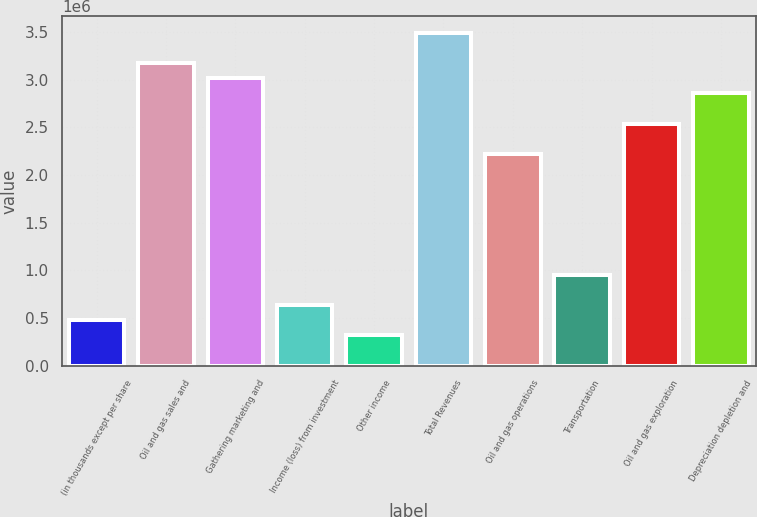Convert chart. <chart><loc_0><loc_0><loc_500><loc_500><bar_chart><fcel>(in thousands except per share<fcel>Oil and gas sales and<fcel>Gathering marketing and<fcel>Income (loss) from investment<fcel>Other income<fcel>Total Revenues<fcel>Oil and gas operations<fcel>Transportation<fcel>Oil and gas exploration<fcel>Depreciation depletion and<nl><fcel>476609<fcel>3.17738e+06<fcel>3.01851e+06<fcel>635477<fcel>317740<fcel>3.49512e+06<fcel>2.22417e+06<fcel>953215<fcel>2.5419e+06<fcel>2.85964e+06<nl></chart> 